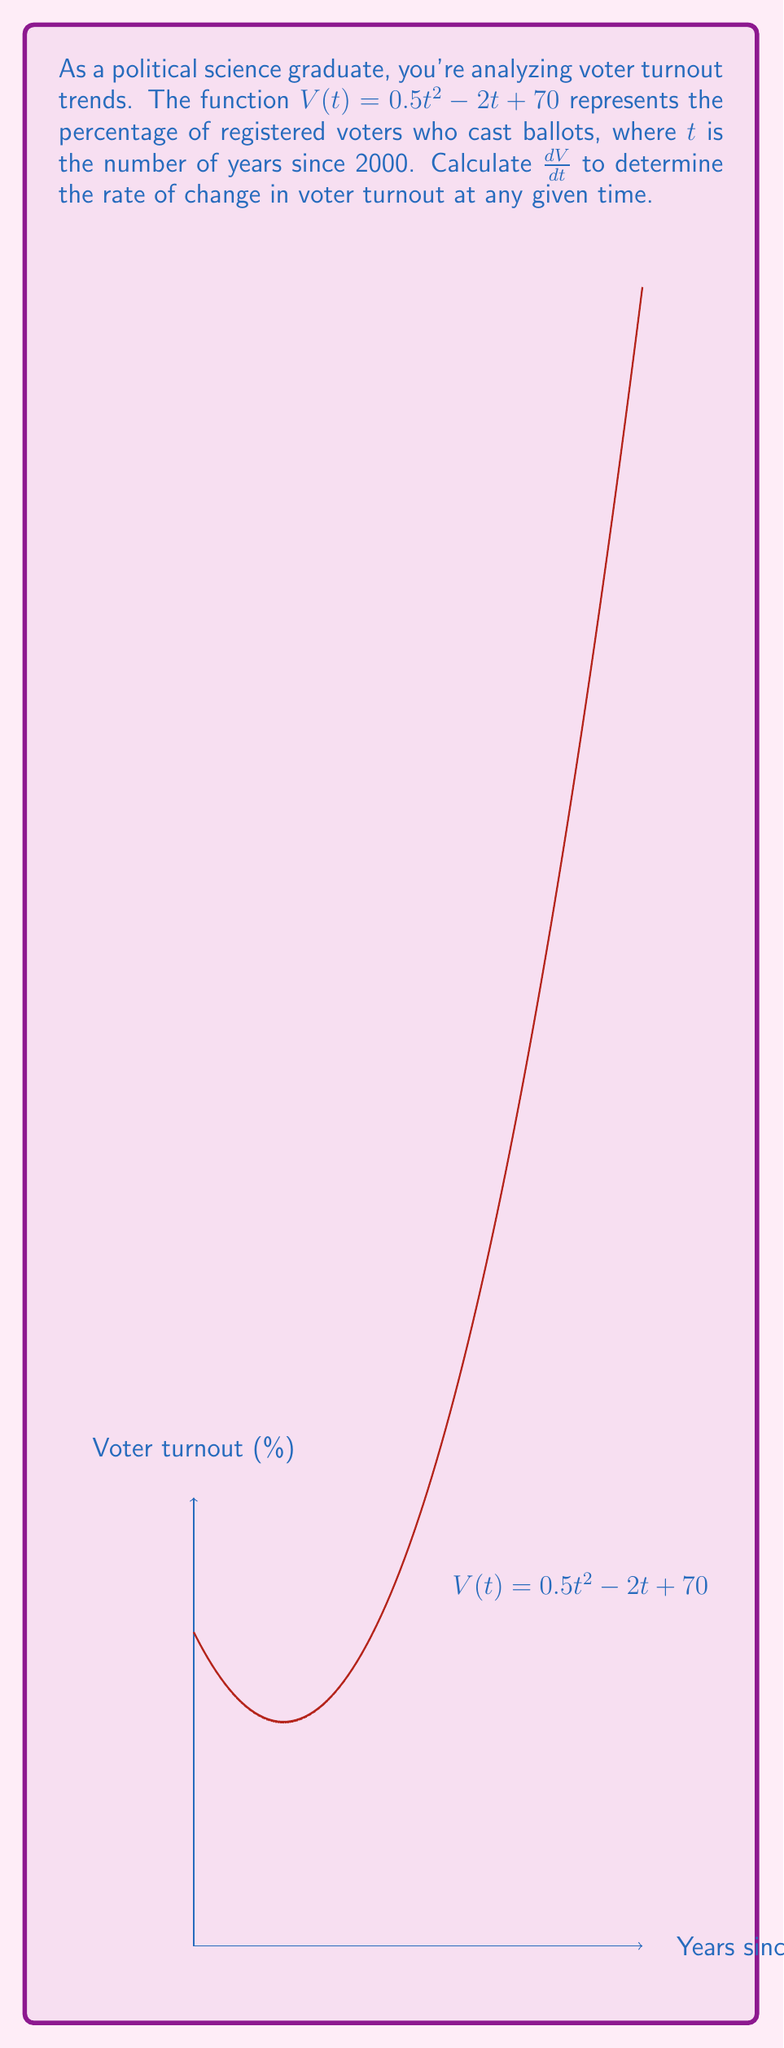Show me your answer to this math problem. To find the derivative of $V(t)$, we'll use the power rule and the constant rule:

1) For the term $0.5t^2$:
   The power rule states that for $ax^n$, the derivative is $nax^{n-1}$.
   So, $\frac{d}{dt}(0.5t^2) = 2 \cdot 0.5 \cdot t^{2-1} = t$

2) For the term $-2t$:
   This is a linear term, so the derivative is the coefficient: $-2$

3) For the constant term $70$:
   The derivative of a constant is always 0.

Combining these results:

$$\frac{dV}{dt} = t - 2 + 0 = t - 2$$

This derivative represents the instantaneous rate of change in voter turnout (in percentage points per year) at any given time $t$.
Answer: $\frac{dV}{dt} = t - 2$ 